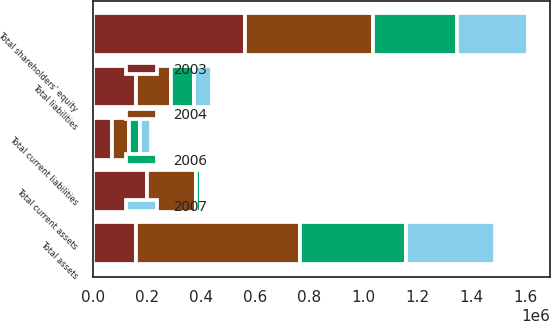<chart> <loc_0><loc_0><loc_500><loc_500><stacked_bar_chart><ecel><fcel>Total current assets<fcel>Total assets<fcel>Total current liabilities<fcel>Total liabilities<fcel>Total shareholders' equity<nl><fcel>2003<fcel>201844<fcel>160005<fcel>73301<fcel>160005<fcel>562110<nl><fcel>2004<fcel>178837<fcel>604208<fcel>61201<fcel>130251<fcel>473957<nl><fcel>2006<fcel>17824<fcel>392495<fcel>41982<fcel>83141<fcel>309354<nl><fcel>2007<fcel>10332<fcel>329653<fcel>38663<fcel>67087<fcel>262566<nl></chart> 